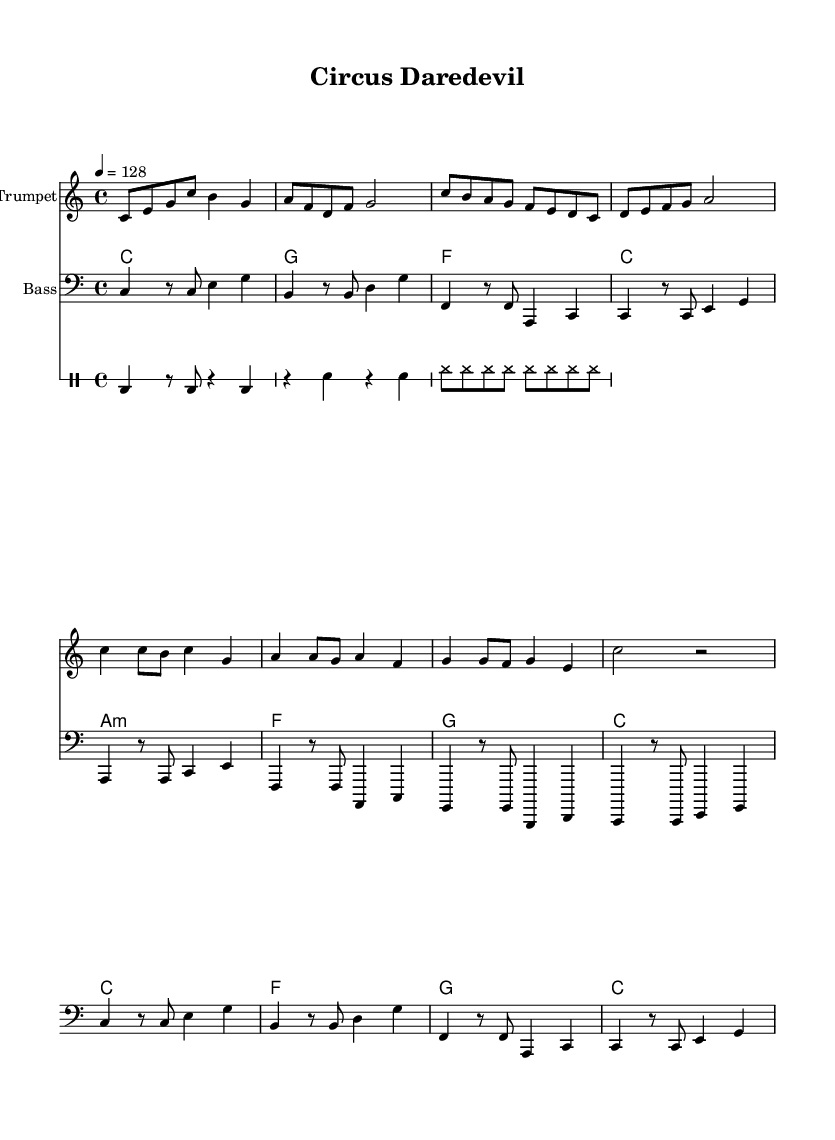What is the key signature of this music? The key signature is C major, which has no sharps or flats.
Answer: C major What is the time signature of this piece? The time signature is indicated at the beginning of the score as 4/4, which means there are four beats in a measure.
Answer: 4/4 What is the tempo marking for this piece? The tempo is specified as 4 equals 128, which sets the speed of the music.
Answer: 128 What instrument plays the introduction? The introduction is played by the trumpet, which is indicated as the instrument name above the corresponding staff.
Answer: Trumpet During which section is the clarinet featured? The clarinet is featured in the verse section, as shown by the specific notes and instrument designation under its staff.
Answer: Verse How many measures are in the chorus section? By counting the measures in the notation for the trumpet chorus, we see there are four measures total.
Answer: Four What type of rhythm is included in the drum pattern? The drum pattern contains a combination of bass drum and snare rhythms, as represented in the drum staff.
Answer: Electro-swing 